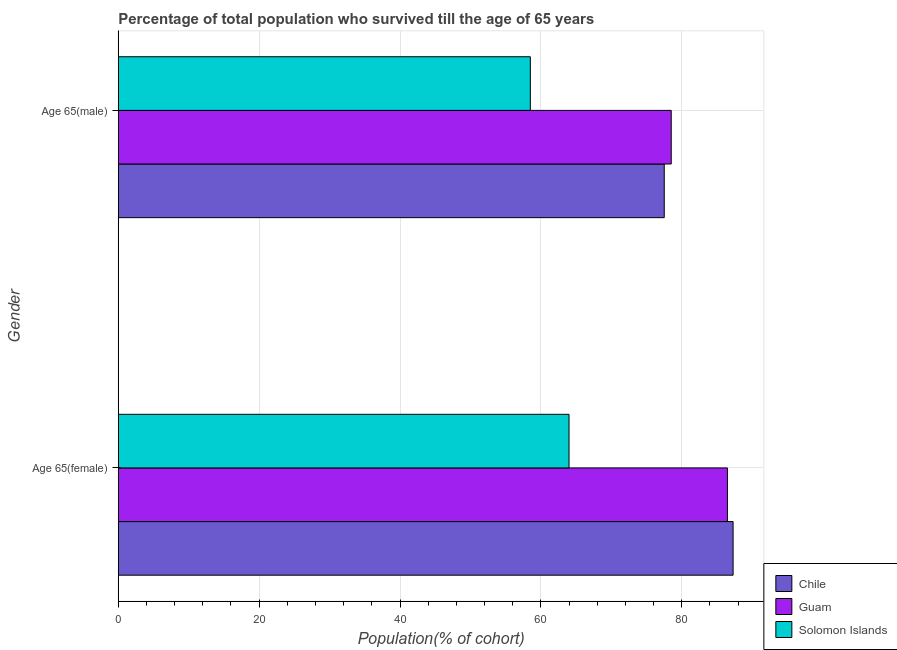Are the number of bars on each tick of the Y-axis equal?
Your answer should be very brief. Yes. What is the label of the 2nd group of bars from the top?
Offer a very short reply. Age 65(female). What is the percentage of male population who survived till age of 65 in Guam?
Your answer should be very brief. 78.51. Across all countries, what is the maximum percentage of female population who survived till age of 65?
Your answer should be compact. 87.3. Across all countries, what is the minimum percentage of male population who survived till age of 65?
Provide a short and direct response. 58.51. In which country was the percentage of male population who survived till age of 65 minimum?
Offer a very short reply. Solomon Islands. What is the total percentage of female population who survived till age of 65 in the graph?
Offer a very short reply. 237.79. What is the difference between the percentage of male population who survived till age of 65 in Chile and that in Solomon Islands?
Provide a short and direct response. 19.01. What is the difference between the percentage of female population who survived till age of 65 in Guam and the percentage of male population who survived till age of 65 in Chile?
Offer a very short reply. 8.97. What is the average percentage of male population who survived till age of 65 per country?
Keep it short and to the point. 71.51. What is the difference between the percentage of female population who survived till age of 65 and percentage of male population who survived till age of 65 in Guam?
Your answer should be very brief. 7.98. In how many countries, is the percentage of male population who survived till age of 65 greater than 76 %?
Offer a very short reply. 2. What is the ratio of the percentage of male population who survived till age of 65 in Guam to that in Solomon Islands?
Provide a succinct answer. 1.34. Is the percentage of male population who survived till age of 65 in Guam less than that in Solomon Islands?
Offer a very short reply. No. What does the 3rd bar from the top in Age 65(male) represents?
Your answer should be compact. Chile. What does the 1st bar from the bottom in Age 65(male) represents?
Offer a terse response. Chile. How many bars are there?
Make the answer very short. 6. Are all the bars in the graph horizontal?
Your answer should be very brief. Yes. Are the values on the major ticks of X-axis written in scientific E-notation?
Your answer should be compact. No. Does the graph contain any zero values?
Keep it short and to the point. No. Where does the legend appear in the graph?
Provide a succinct answer. Bottom right. How many legend labels are there?
Provide a succinct answer. 3. How are the legend labels stacked?
Your answer should be very brief. Vertical. What is the title of the graph?
Provide a succinct answer. Percentage of total population who survived till the age of 65 years. Does "United States" appear as one of the legend labels in the graph?
Your answer should be very brief. No. What is the label or title of the X-axis?
Provide a short and direct response. Population(% of cohort). What is the Population(% of cohort) in Chile in Age 65(female)?
Keep it short and to the point. 87.3. What is the Population(% of cohort) in Guam in Age 65(female)?
Your response must be concise. 86.49. What is the Population(% of cohort) of Solomon Islands in Age 65(female)?
Your response must be concise. 64. What is the Population(% of cohort) in Chile in Age 65(male)?
Your answer should be compact. 77.52. What is the Population(% of cohort) in Guam in Age 65(male)?
Provide a short and direct response. 78.51. What is the Population(% of cohort) in Solomon Islands in Age 65(male)?
Give a very brief answer. 58.51. Across all Gender, what is the maximum Population(% of cohort) of Chile?
Offer a terse response. 87.3. Across all Gender, what is the maximum Population(% of cohort) in Guam?
Your response must be concise. 86.49. Across all Gender, what is the maximum Population(% of cohort) of Solomon Islands?
Give a very brief answer. 64. Across all Gender, what is the minimum Population(% of cohort) of Chile?
Offer a terse response. 77.52. Across all Gender, what is the minimum Population(% of cohort) in Guam?
Your response must be concise. 78.51. Across all Gender, what is the minimum Population(% of cohort) of Solomon Islands?
Your response must be concise. 58.51. What is the total Population(% of cohort) in Chile in the graph?
Your response must be concise. 164.82. What is the total Population(% of cohort) of Guam in the graph?
Make the answer very short. 165. What is the total Population(% of cohort) of Solomon Islands in the graph?
Keep it short and to the point. 122.51. What is the difference between the Population(% of cohort) in Chile in Age 65(female) and that in Age 65(male)?
Provide a succinct answer. 9.78. What is the difference between the Population(% of cohort) of Guam in Age 65(female) and that in Age 65(male)?
Give a very brief answer. 7.98. What is the difference between the Population(% of cohort) in Solomon Islands in Age 65(female) and that in Age 65(male)?
Ensure brevity in your answer.  5.49. What is the difference between the Population(% of cohort) in Chile in Age 65(female) and the Population(% of cohort) in Guam in Age 65(male)?
Make the answer very short. 8.79. What is the difference between the Population(% of cohort) in Chile in Age 65(female) and the Population(% of cohort) in Solomon Islands in Age 65(male)?
Make the answer very short. 28.79. What is the difference between the Population(% of cohort) in Guam in Age 65(female) and the Population(% of cohort) in Solomon Islands in Age 65(male)?
Make the answer very short. 27.98. What is the average Population(% of cohort) in Chile per Gender?
Your answer should be compact. 82.41. What is the average Population(% of cohort) in Guam per Gender?
Give a very brief answer. 82.5. What is the average Population(% of cohort) of Solomon Islands per Gender?
Keep it short and to the point. 61.25. What is the difference between the Population(% of cohort) of Chile and Population(% of cohort) of Guam in Age 65(female)?
Your response must be concise. 0.8. What is the difference between the Population(% of cohort) of Chile and Population(% of cohort) of Solomon Islands in Age 65(female)?
Make the answer very short. 23.29. What is the difference between the Population(% of cohort) of Guam and Population(% of cohort) of Solomon Islands in Age 65(female)?
Offer a terse response. 22.49. What is the difference between the Population(% of cohort) in Chile and Population(% of cohort) in Guam in Age 65(male)?
Offer a very short reply. -0.99. What is the difference between the Population(% of cohort) in Chile and Population(% of cohort) in Solomon Islands in Age 65(male)?
Offer a terse response. 19.01. What is the difference between the Population(% of cohort) of Guam and Population(% of cohort) of Solomon Islands in Age 65(male)?
Provide a succinct answer. 20. What is the ratio of the Population(% of cohort) in Chile in Age 65(female) to that in Age 65(male)?
Make the answer very short. 1.13. What is the ratio of the Population(% of cohort) in Guam in Age 65(female) to that in Age 65(male)?
Your answer should be very brief. 1.1. What is the ratio of the Population(% of cohort) in Solomon Islands in Age 65(female) to that in Age 65(male)?
Offer a very short reply. 1.09. What is the difference between the highest and the second highest Population(% of cohort) in Chile?
Give a very brief answer. 9.78. What is the difference between the highest and the second highest Population(% of cohort) of Guam?
Ensure brevity in your answer.  7.98. What is the difference between the highest and the second highest Population(% of cohort) in Solomon Islands?
Your response must be concise. 5.49. What is the difference between the highest and the lowest Population(% of cohort) in Chile?
Make the answer very short. 9.78. What is the difference between the highest and the lowest Population(% of cohort) in Guam?
Provide a short and direct response. 7.98. What is the difference between the highest and the lowest Population(% of cohort) in Solomon Islands?
Offer a very short reply. 5.49. 